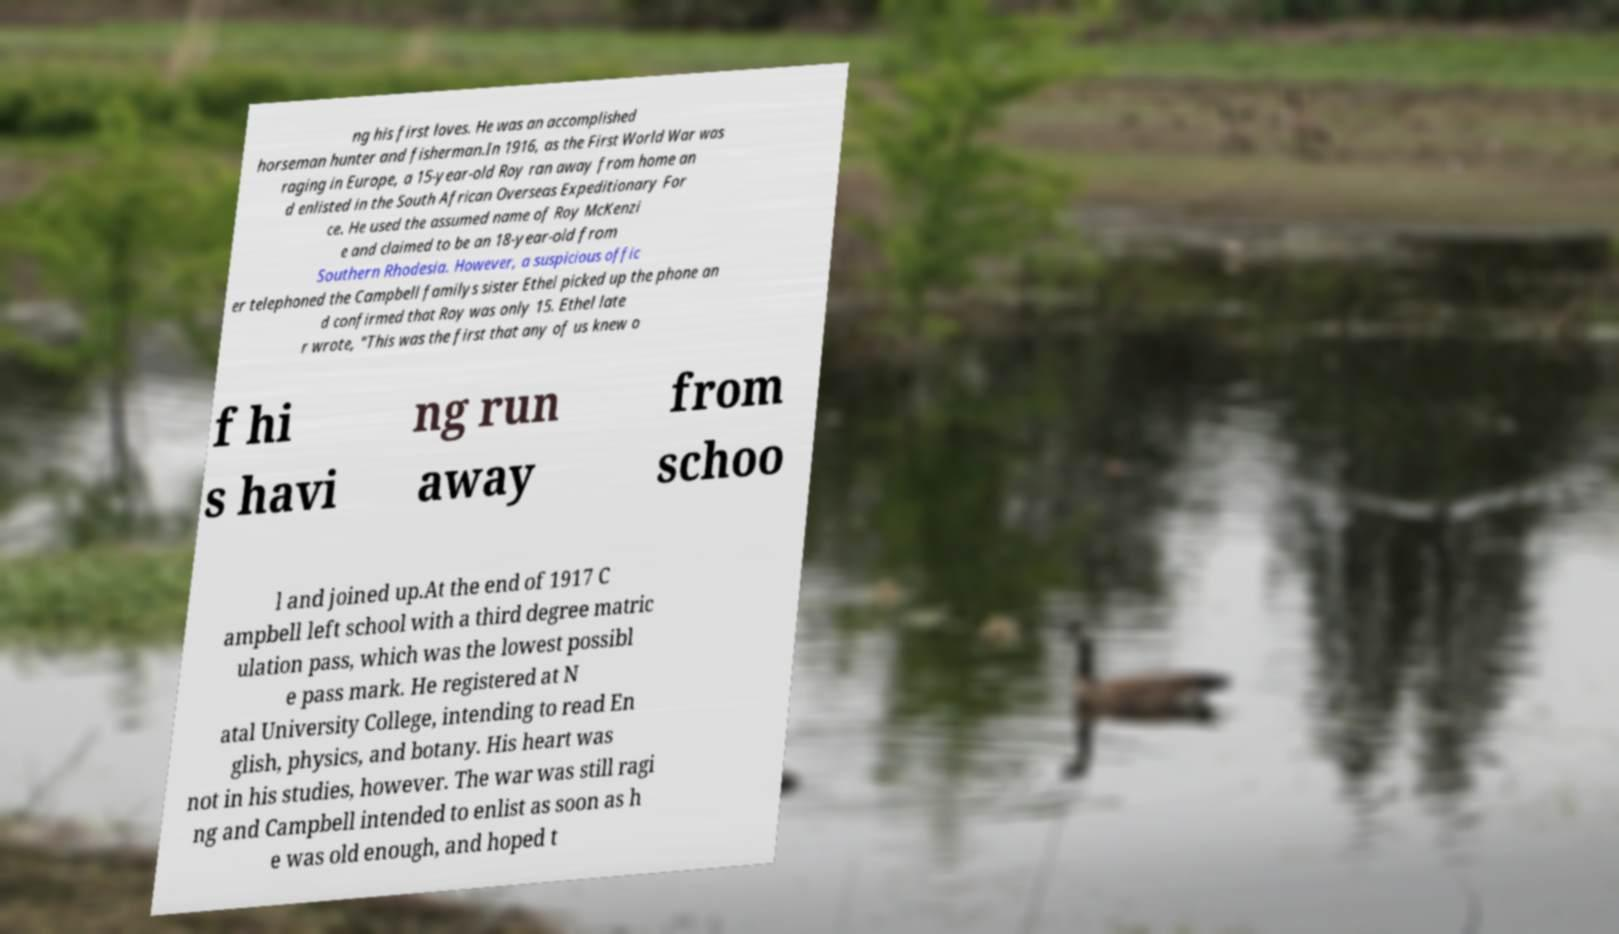For documentation purposes, I need the text within this image transcribed. Could you provide that? ng his first loves. He was an accomplished horseman hunter and fisherman.In 1916, as the First World War was raging in Europe, a 15-year-old Roy ran away from home an d enlisted in the South African Overseas Expeditionary For ce. He used the assumed name of Roy McKenzi e and claimed to be an 18-year-old from Southern Rhodesia. However, a suspicious offic er telephoned the Campbell familys sister Ethel picked up the phone an d confirmed that Roy was only 15. Ethel late r wrote, "This was the first that any of us knew o f hi s havi ng run away from schoo l and joined up.At the end of 1917 C ampbell left school with a third degree matric ulation pass, which was the lowest possibl e pass mark. He registered at N atal University College, intending to read En glish, physics, and botany. His heart was not in his studies, however. The war was still ragi ng and Campbell intended to enlist as soon as h e was old enough, and hoped t 